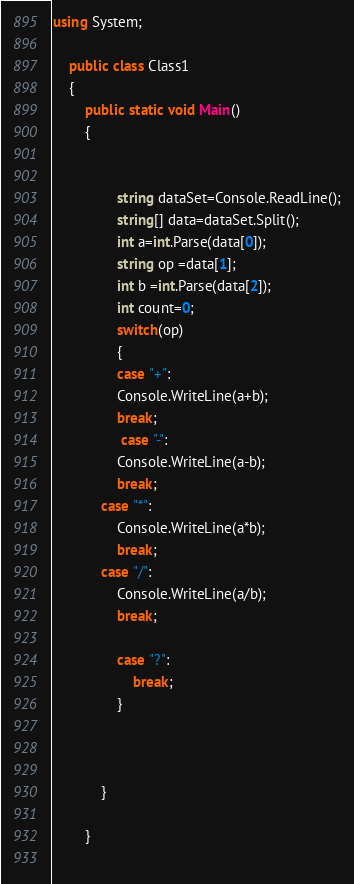Convert code to text. <code><loc_0><loc_0><loc_500><loc_500><_C#_>using System;

	public class Class1
	{
		public static void Main()
		{   
		
			
				string dataSet=Console.ReadLine();
				string[] data=dataSet.Split();
				int a=int.Parse(data[0]);
				string op =data[1];
				int b =int.Parse(data[2]);
				int count=0;
				switch(op)
				{
				case "+":
				Console.WriteLine(a+b);
				break;
			     case "-":
				Console.WriteLine(a-b);
				break;
			case "*":
				Console.WriteLine(a*b);
				break;
			case "/":
				Console.WriteLine(a/b);
				break;
				
				case "?":
					break;
				}
					
			    
				
			}
			
		}
	</code> 